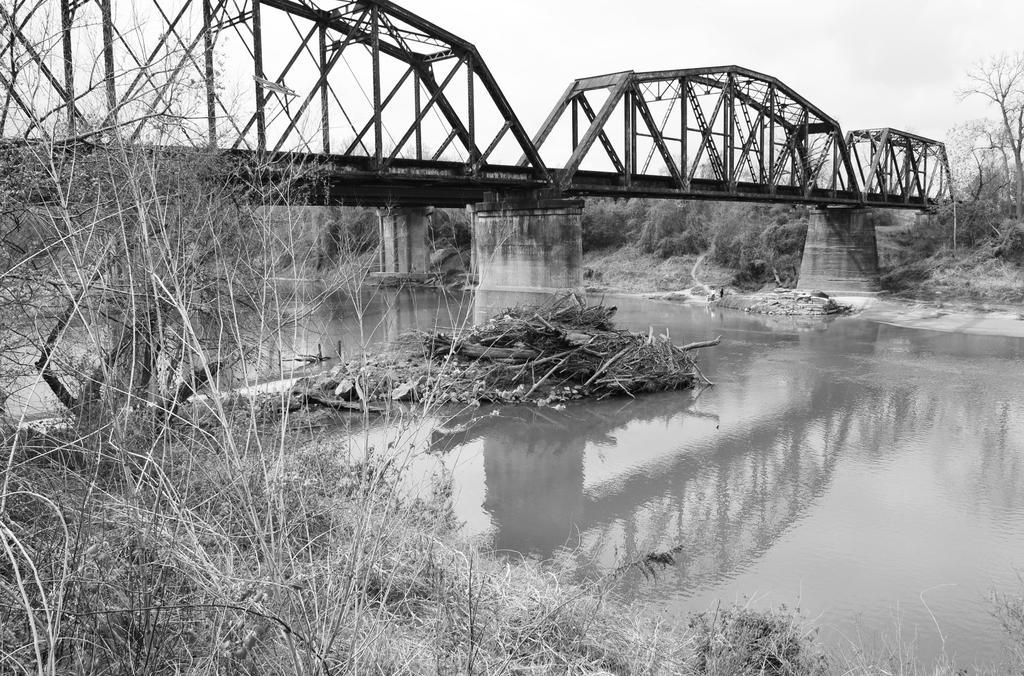How would you summarize this image in a sentence or two? In this image there is a river in the middle of this image and there is a bridge on the top of this image and there are some trees in the background. There are some trees on the left side of this image as well. There is a sky on the top of this image. 